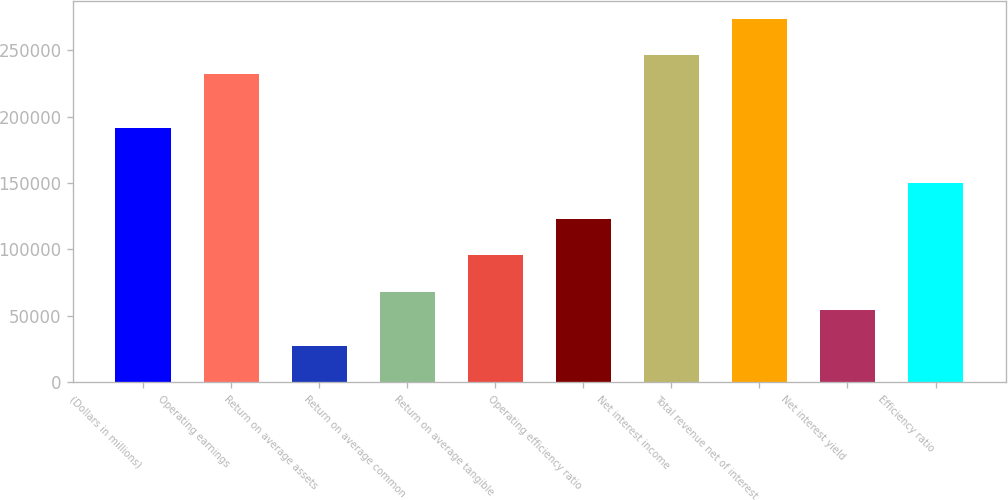<chart> <loc_0><loc_0><loc_500><loc_500><bar_chart><fcel>(Dollars in millions)<fcel>Operating earnings<fcel>Return on average assets<fcel>Return on average common<fcel>Return on average tangible<fcel>Operating efficiency ratio<fcel>Net interest income<fcel>Total revenue net of interest<fcel>Net interest yield<fcel>Efficiency ratio<nl><fcel>191327<fcel>232325<fcel>27332.4<fcel>68331<fcel>95663.4<fcel>122996<fcel>245992<fcel>273324<fcel>54664.8<fcel>150328<nl></chart> 